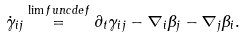<formula> <loc_0><loc_0><loc_500><loc_500>\dot { \gamma } _ { i j } \overset { \lim f u n c { d e f } } { = } \partial _ { t } \gamma _ { i j } - \nabla _ { i } \beta _ { j } - \nabla _ { j } \beta _ { i } .</formula> 